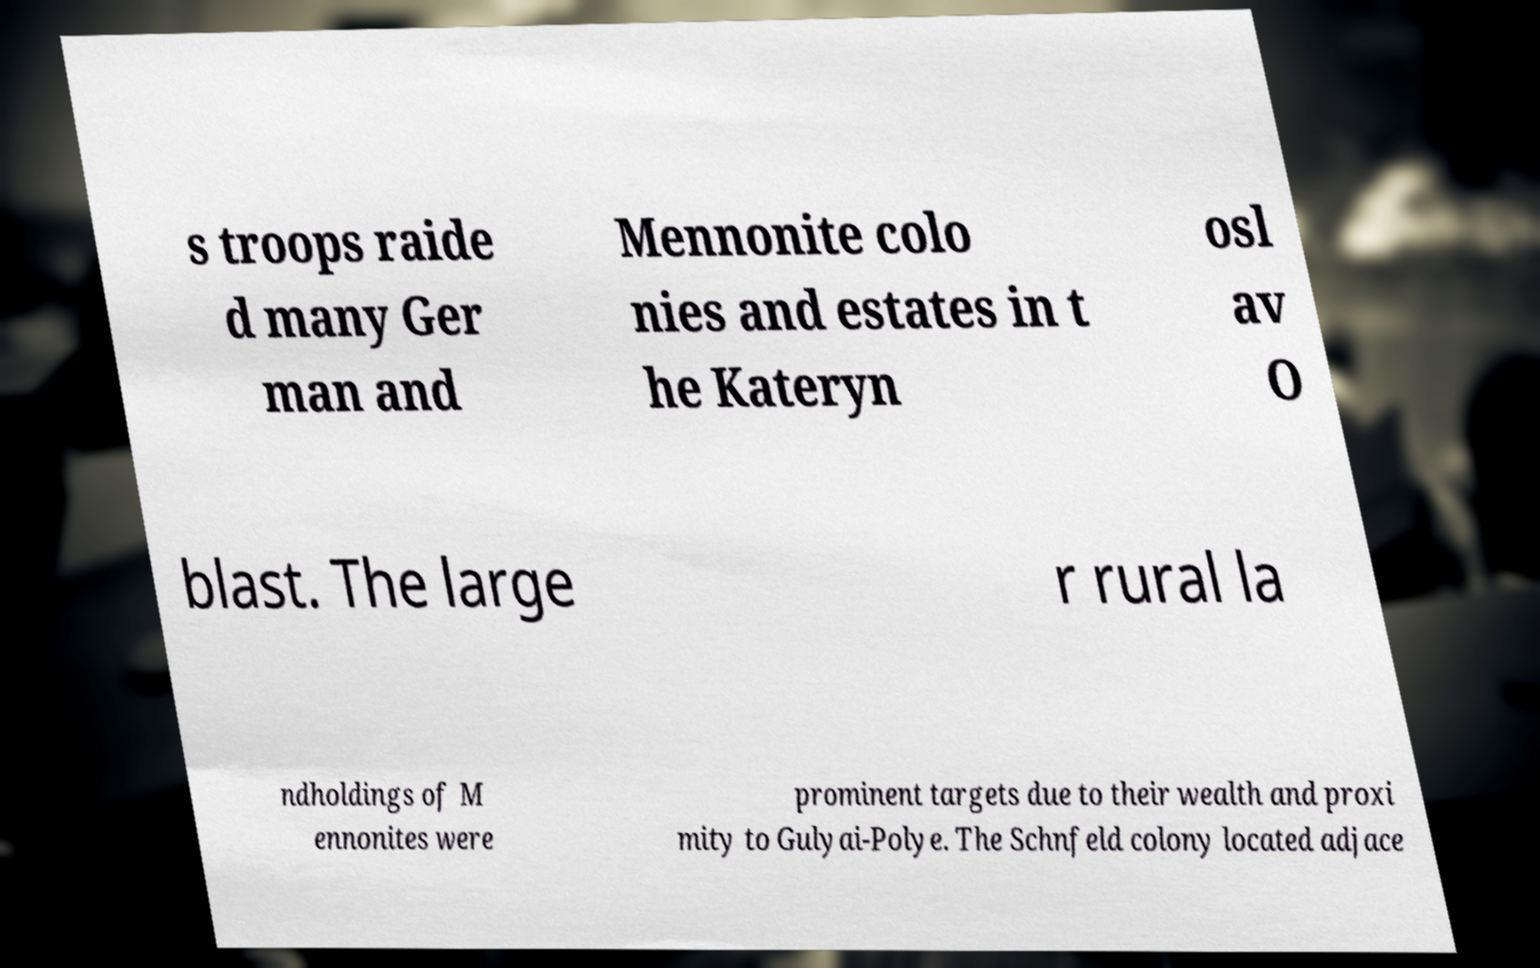What messages or text are displayed in this image? I need them in a readable, typed format. s troops raide d many Ger man and Mennonite colo nies and estates in t he Kateryn osl av O blast. The large r rural la ndholdings of M ennonites were prominent targets due to their wealth and proxi mity to Gulyai-Polye. The Schnfeld colony located adjace 